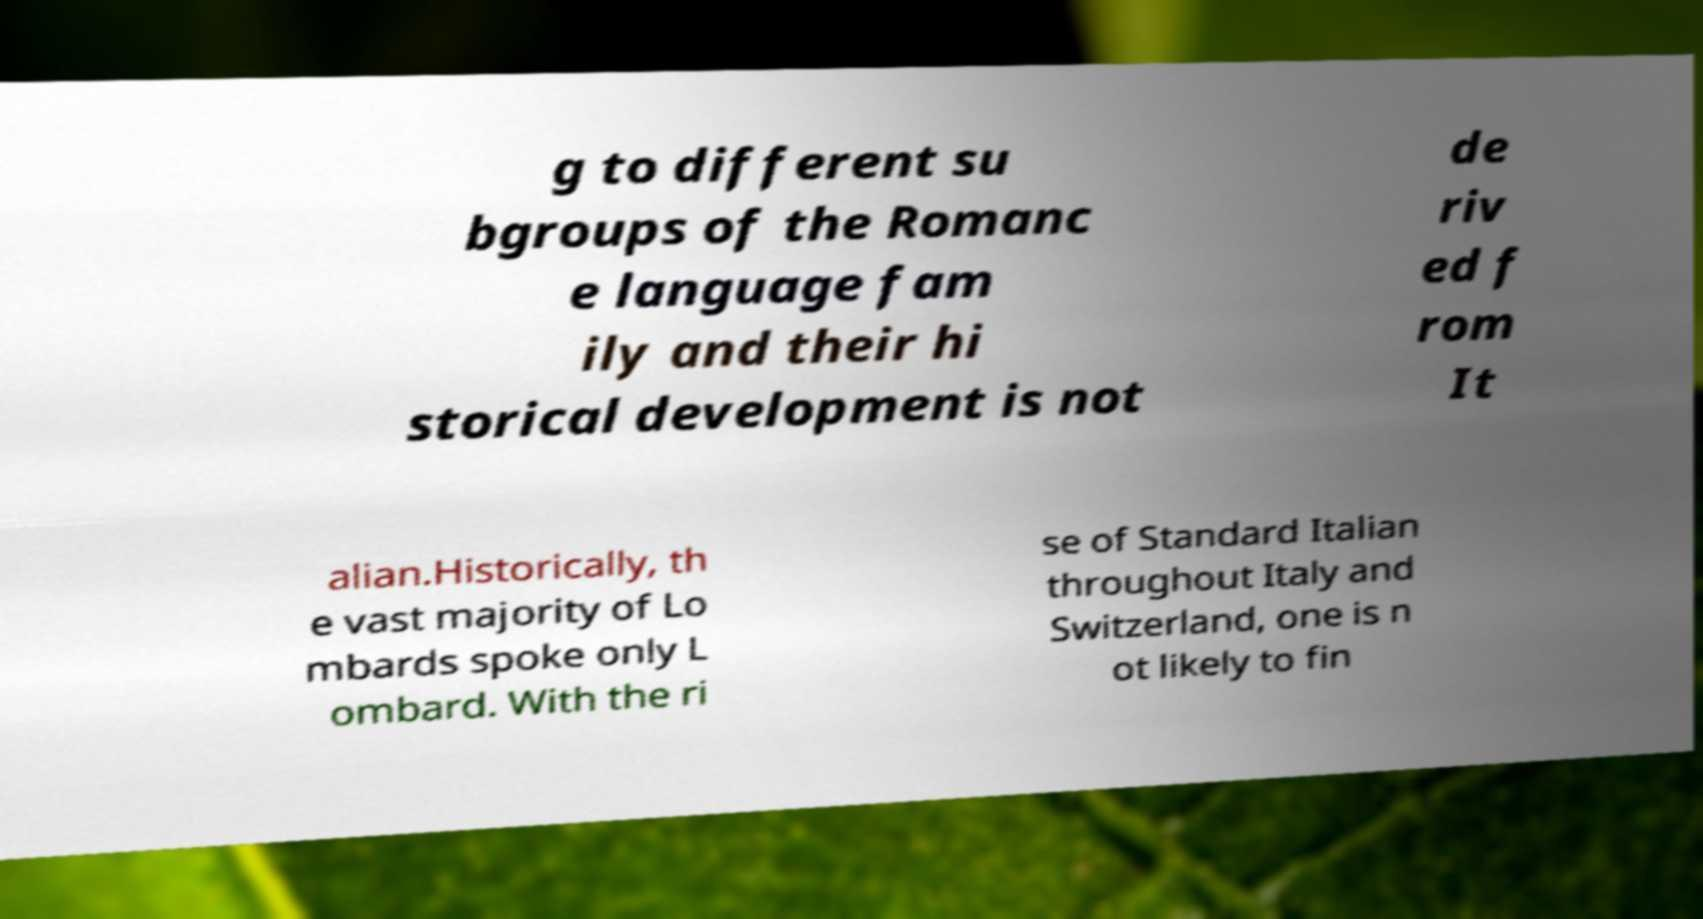What messages or text are displayed in this image? I need them in a readable, typed format. g to different su bgroups of the Romanc e language fam ily and their hi storical development is not de riv ed f rom It alian.Historically, th e vast majority of Lo mbards spoke only L ombard. With the ri se of Standard Italian throughout Italy and Switzerland, one is n ot likely to fin 